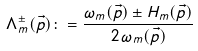Convert formula to latex. <formula><loc_0><loc_0><loc_500><loc_500>\Lambda ^ { \pm } _ { m } ( \vec { p } ) \colon = \frac { \omega _ { m } ( \vec { p } ) \pm H _ { m } ( \vec { p } ) } { 2 \, \omega _ { m } ( \vec { p } ) }</formula> 